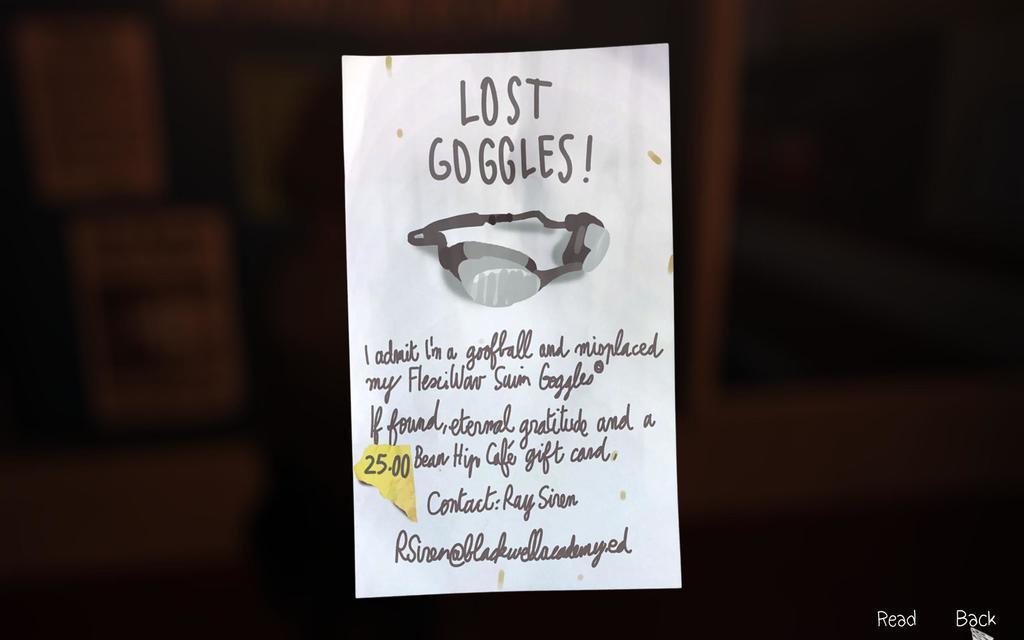How would you summarize this image in a sentence or two? In this image we can able to see a paper note with some text written on it, there is a google image on it. 